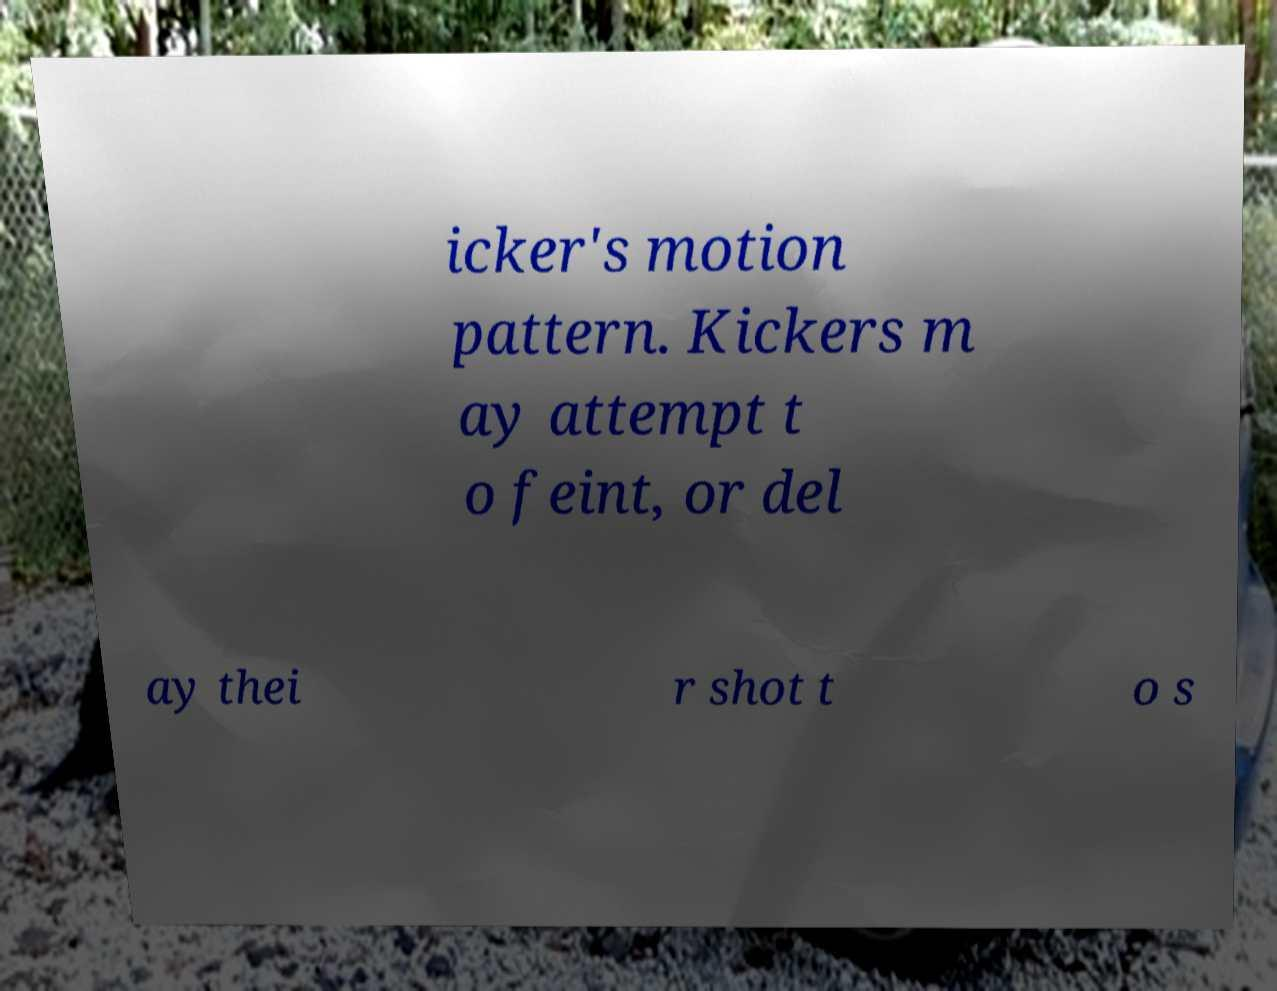What messages or text are displayed in this image? I need them in a readable, typed format. icker's motion pattern. Kickers m ay attempt t o feint, or del ay thei r shot t o s 